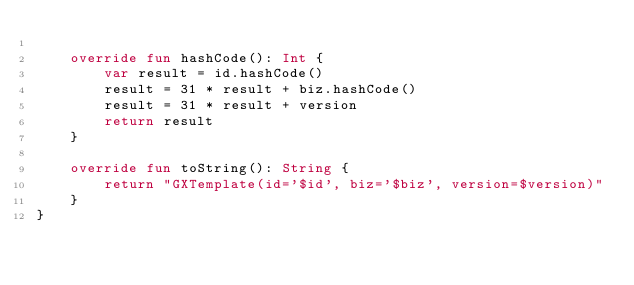Convert code to text. <code><loc_0><loc_0><loc_500><loc_500><_Kotlin_>
    override fun hashCode(): Int {
        var result = id.hashCode()
        result = 31 * result + biz.hashCode()
        result = 31 * result + version
        return result
    }

    override fun toString(): String {
        return "GXTemplate(id='$id', biz='$biz', version=$version)"
    }
}</code> 